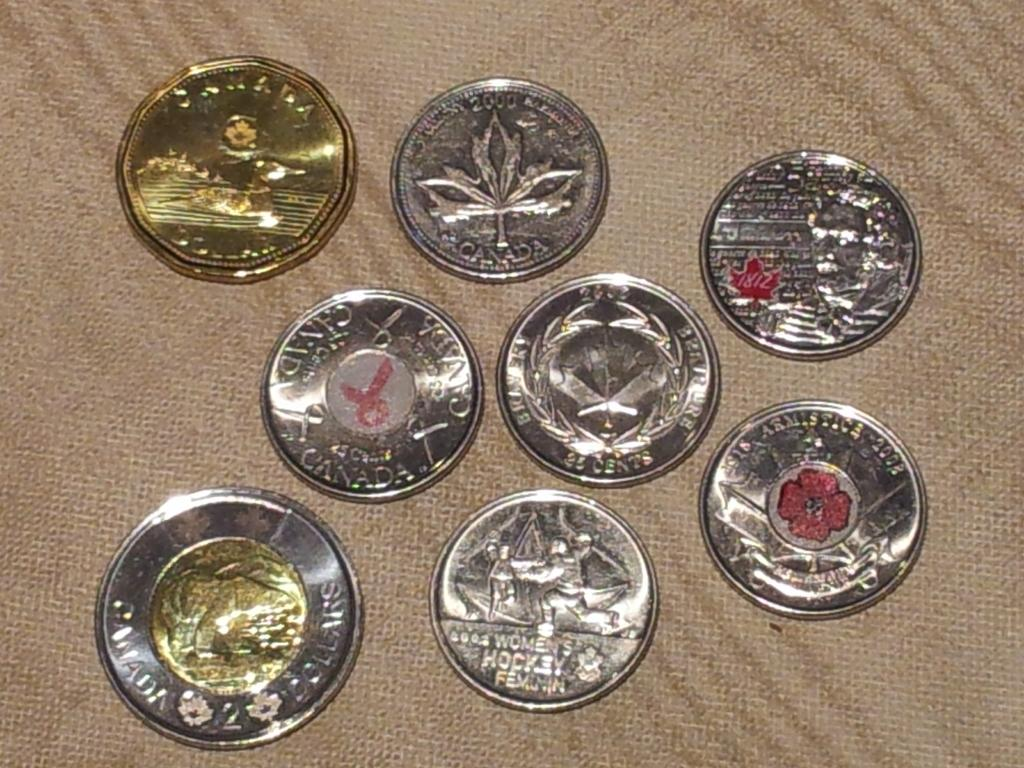<image>
Give a short and clear explanation of the subsequent image. Several silver coins and one gold coin bearing the words Canada 